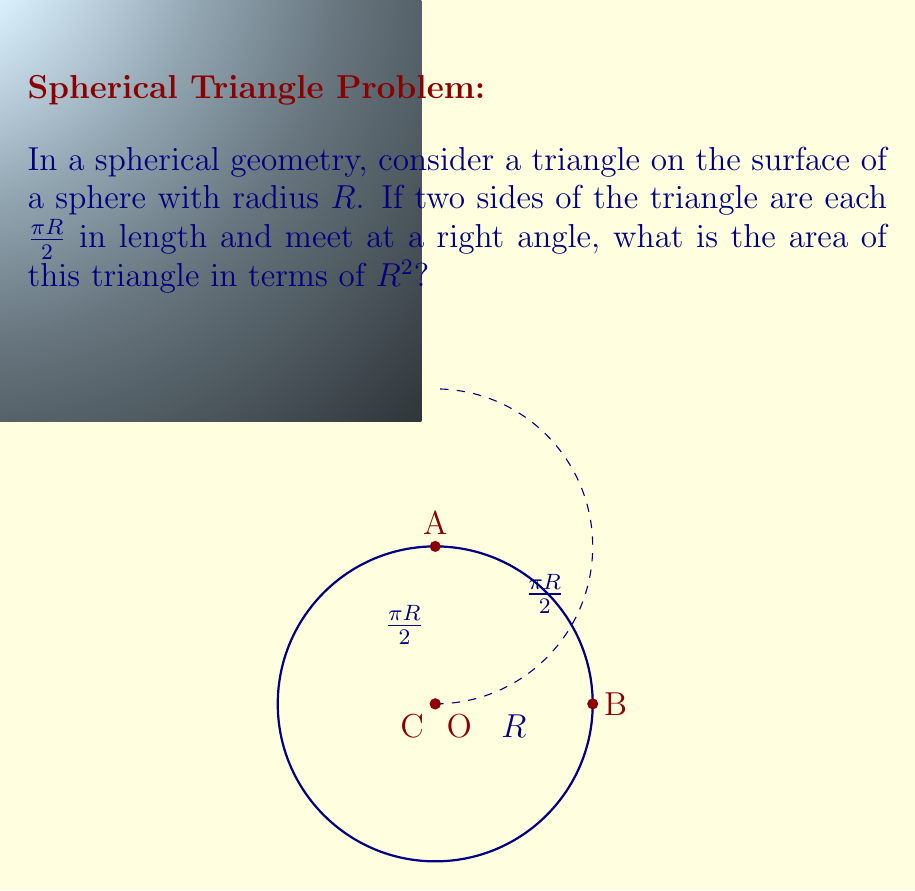Show me your answer to this math problem. Let's approach this step-by-step:

1) In spherical geometry, the area of a triangle is given by the formula:

   $A = R^2(α + β + γ - π)$

   where $α$, $β$, and $γ$ are the angles of the triangle, and $R$ is the radius of the sphere.

2) We know two sides of the triangle are $\frac{\pi R}{2}$ and they meet at a right angle. In spherical geometry, the length of an arc is related to its central angle by:

   $l = R\theta$

   where $l$ is the arc length, $R$ is the radius, and $\theta$ is the central angle in radians.

3) For our two known sides:

   $\frac{\pi R}{2} = R\theta$

   Simplifying:
   $\theta = \frac{\pi}{2}$

4) This means that two of our angles, let's call them $α$ and $β$, are $\frac{\pi}{2}$.

5) We're also told that these two sides meet at a right angle, so $γ = \frac{\pi}{2}$ as well.

6) Now we can plug these values into our area formula:

   $A = R^2(\frac{\pi}{2} + \frac{\pi}{2} + \frac{\pi}{2} - π)$

7) Simplifying:

   $A = R^2(\frac{3π}{2} - π) = R^2(\frac{π}{2}) = \frac{\pi R^2}{2}$

Thus, the area of the triangle is $\frac{\pi R^2}{2}$.
Answer: $\frac{\pi R^2}{2}$ 